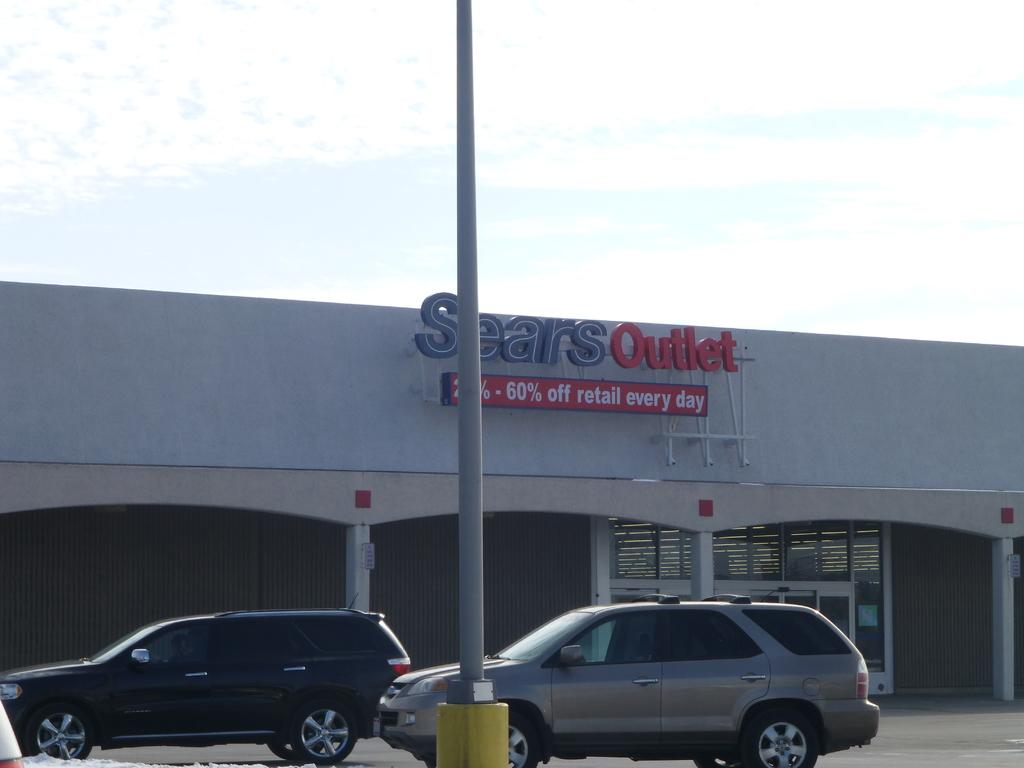What types of vehicles are in the image? There are vehicles in the image, but the specific types are not mentioned. What is the pole on the ground used for in the image? The purpose of the pole on the ground is not mentioned in the facts. What can be seen in the background of the image? In the background of the image, there is a building, an LED board, the sky, and other objects. How many vehicles are in the image? The number of vehicles in the image is not mentioned in the facts. What is the color of the sky in the image? The color of the sky in the image is not mentioned in the facts. How many ducks are sitting on the crib in the image? There are no ducks or cribs present in the image. What type of door is visible in the image? There is no door mentioned or visible in the image. 